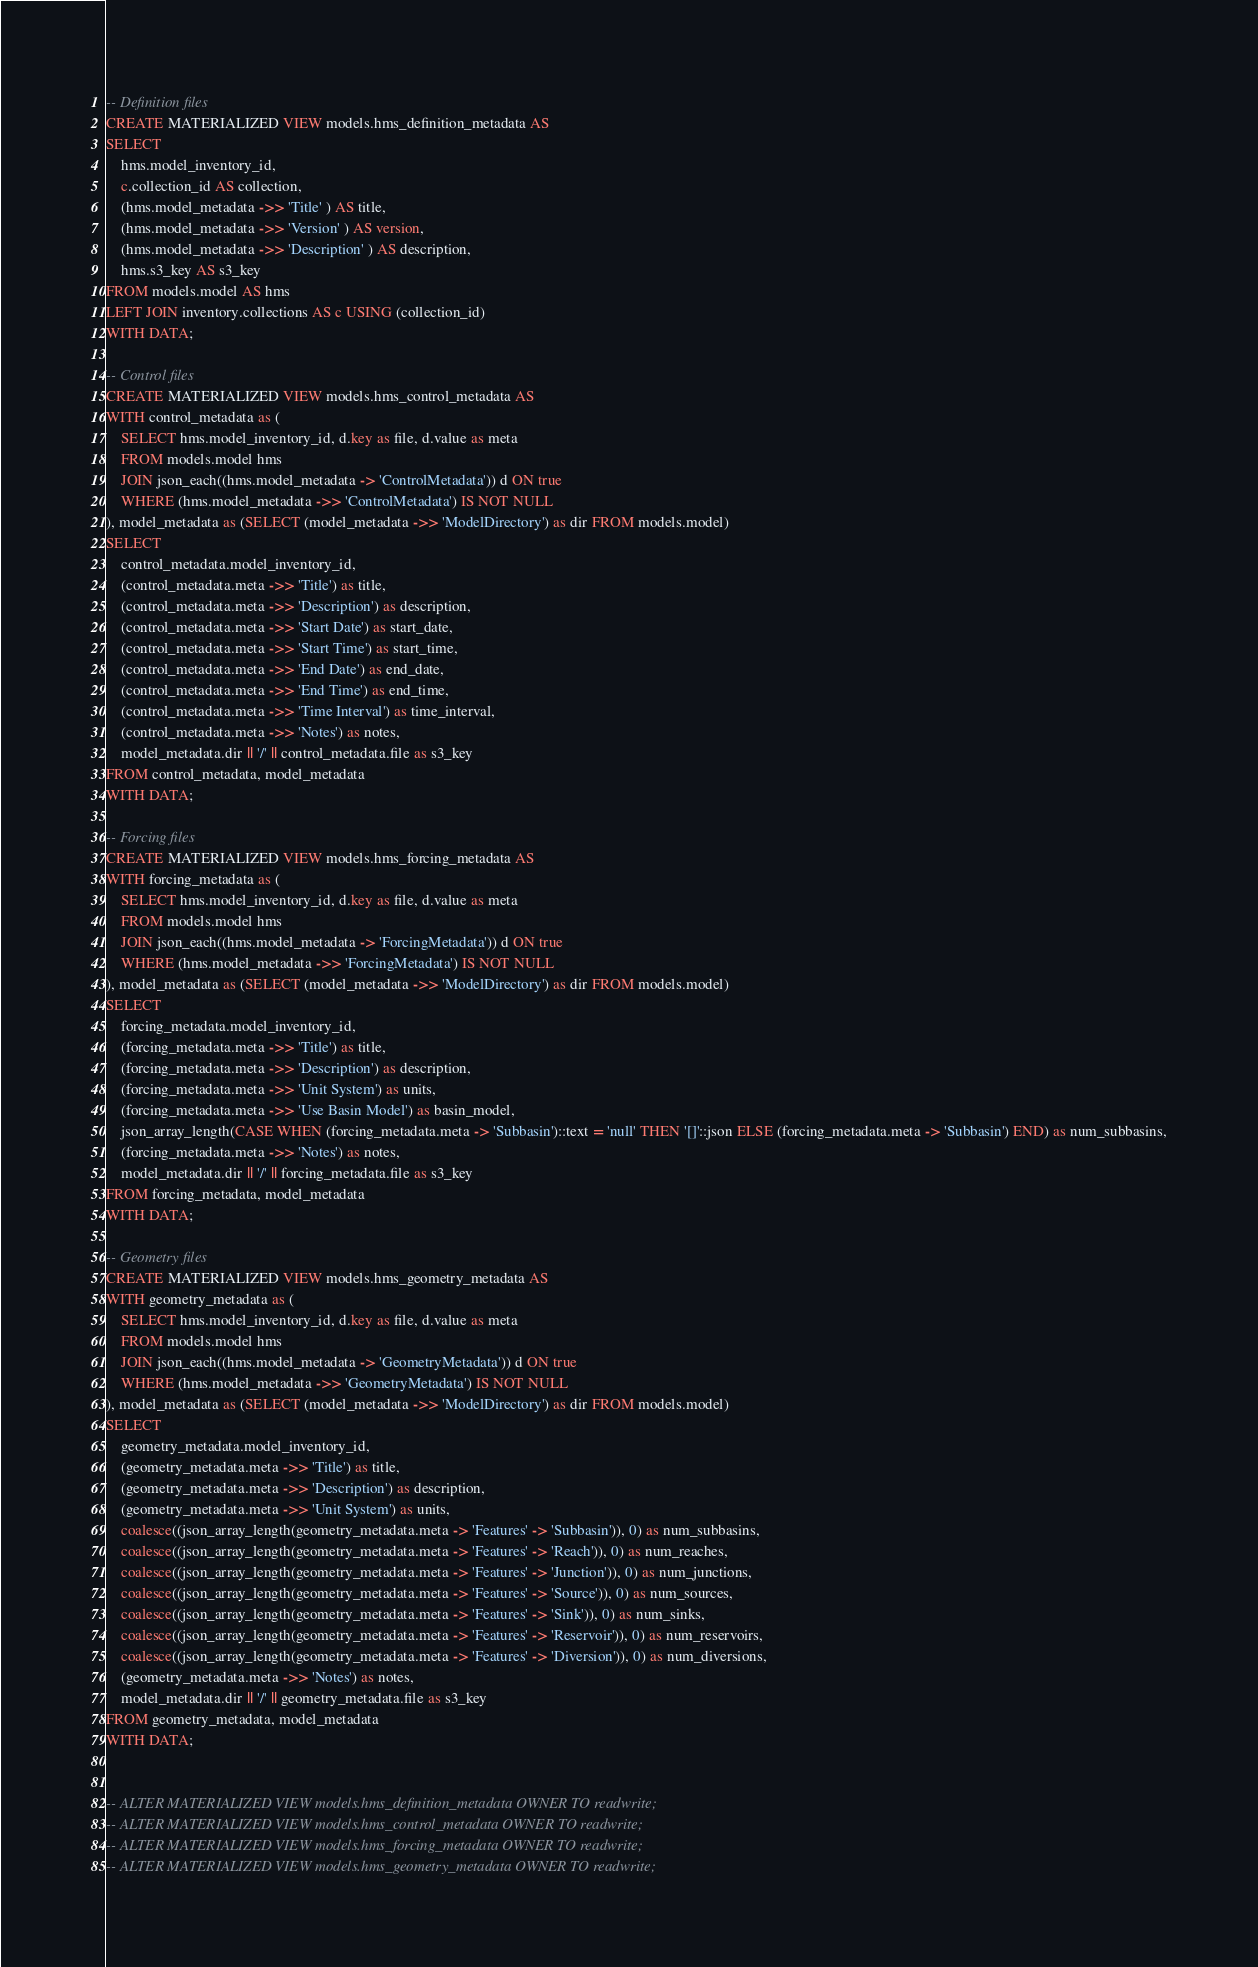<code> <loc_0><loc_0><loc_500><loc_500><_SQL_>-- Definition files
CREATE MATERIALIZED VIEW models.hms_definition_metadata AS
SELECT
    hms.model_inventory_id,
    c.collection_id AS collection,
    (hms.model_metadata ->> 'Title' ) AS title,
    (hms.model_metadata ->> 'Version' ) AS version,
    (hms.model_metadata ->> 'Description' ) AS description,
    hms.s3_key AS s3_key
FROM models.model AS hms
LEFT JOIN inventory.collections AS c USING (collection_id)
WITH DATA;

-- Control files 
CREATE MATERIALIZED VIEW models.hms_control_metadata AS
WITH control_metadata as (
    SELECT hms.model_inventory_id, d.key as file, d.value as meta
    FROM models.model hms
    JOIN json_each((hms.model_metadata -> 'ControlMetadata')) d ON true
    WHERE (hms.model_metadata ->> 'ControlMetadata') IS NOT NULL
), model_metadata as (SELECT (model_metadata ->> 'ModelDirectory') as dir FROM models.model)
SELECT 
    control_metadata.model_inventory_id, 
    (control_metadata.meta ->> 'Title') as title, 
    (control_metadata.meta ->> 'Description') as description,
    (control_metadata.meta ->> 'Start Date') as start_date,
    (control_metadata.meta ->> 'Start Time') as start_time,
    (control_metadata.meta ->> 'End Date') as end_date,
    (control_metadata.meta ->> 'End Time') as end_time,
    (control_metadata.meta ->> 'Time Interval') as time_interval,
    (control_metadata.meta ->> 'Notes') as notes,
    model_metadata.dir || '/' || control_metadata.file as s3_key
FROM control_metadata, model_metadata
WITH DATA;

-- Forcing files 
CREATE MATERIALIZED VIEW models.hms_forcing_metadata AS
WITH forcing_metadata as (
    SELECT hms.model_inventory_id, d.key as file, d.value as meta 
    FROM models.model hms
    JOIN json_each((hms.model_metadata -> 'ForcingMetadata')) d ON true
    WHERE (hms.model_metadata ->> 'ForcingMetadata') IS NOT NULL
), model_metadata as (SELECT (model_metadata ->> 'ModelDirectory') as dir FROM models.model)
SELECT 
    forcing_metadata.model_inventory_id, 
    (forcing_metadata.meta ->> 'Title') as title, 
    (forcing_metadata.meta ->> 'Description') as description,
    (forcing_metadata.meta ->> 'Unit System') as units,
    (forcing_metadata.meta ->> 'Use Basin Model') as basin_model,
    json_array_length(CASE WHEN (forcing_metadata.meta -> 'Subbasin')::text = 'null' THEN '[]'::json ELSE (forcing_metadata.meta -> 'Subbasin') END) as num_subbasins,
    (forcing_metadata.meta ->> 'Notes') as notes,
    model_metadata.dir || '/' || forcing_metadata.file as s3_key
FROM forcing_metadata, model_metadata
WITH DATA;

-- Geometry files 
CREATE MATERIALIZED VIEW models.hms_geometry_metadata AS
WITH geometry_metadata as (
    SELECT hms.model_inventory_id, d.key as file, d.value as meta
    FROM models.model hms
    JOIN json_each((hms.model_metadata -> 'GeometryMetadata')) d ON true
    WHERE (hms.model_metadata ->> 'GeometryMetadata') IS NOT NULL
), model_metadata as (SELECT (model_metadata ->> 'ModelDirectory') as dir FROM models.model)
SELECT 
    geometry_metadata.model_inventory_id, 
    (geometry_metadata.meta ->> 'Title') as title, 
    (geometry_metadata.meta ->> 'Description') as description,
    (geometry_metadata.meta ->> 'Unit System') as units,
    coalesce((json_array_length(geometry_metadata.meta -> 'Features' -> 'Subbasin')), 0) as num_subbasins,
    coalesce((json_array_length(geometry_metadata.meta -> 'Features' -> 'Reach')), 0) as num_reaches,
    coalesce((json_array_length(geometry_metadata.meta -> 'Features' -> 'Junction')), 0) as num_junctions,
    coalesce((json_array_length(geometry_metadata.meta -> 'Features' -> 'Source')), 0) as num_sources,
    coalesce((json_array_length(geometry_metadata.meta -> 'Features' -> 'Sink')), 0) as num_sinks,
    coalesce((json_array_length(geometry_metadata.meta -> 'Features' -> 'Reservoir')), 0) as num_reservoirs,
    coalesce((json_array_length(geometry_metadata.meta -> 'Features' -> 'Diversion')), 0) as num_diversions,
    (geometry_metadata.meta ->> 'Notes') as notes,
    model_metadata.dir || '/' || geometry_metadata.file as s3_key
FROM geometry_metadata, model_metadata
WITH DATA;


-- ALTER MATERIALIZED VIEW models.hms_definition_metadata OWNER TO readwrite;
-- ALTER MATERIALIZED VIEW models.hms_control_metadata OWNER TO readwrite;
-- ALTER MATERIALIZED VIEW models.hms_forcing_metadata OWNER TO readwrite;
-- ALTER MATERIALIZED VIEW models.hms_geometry_metadata OWNER TO readwrite;</code> 